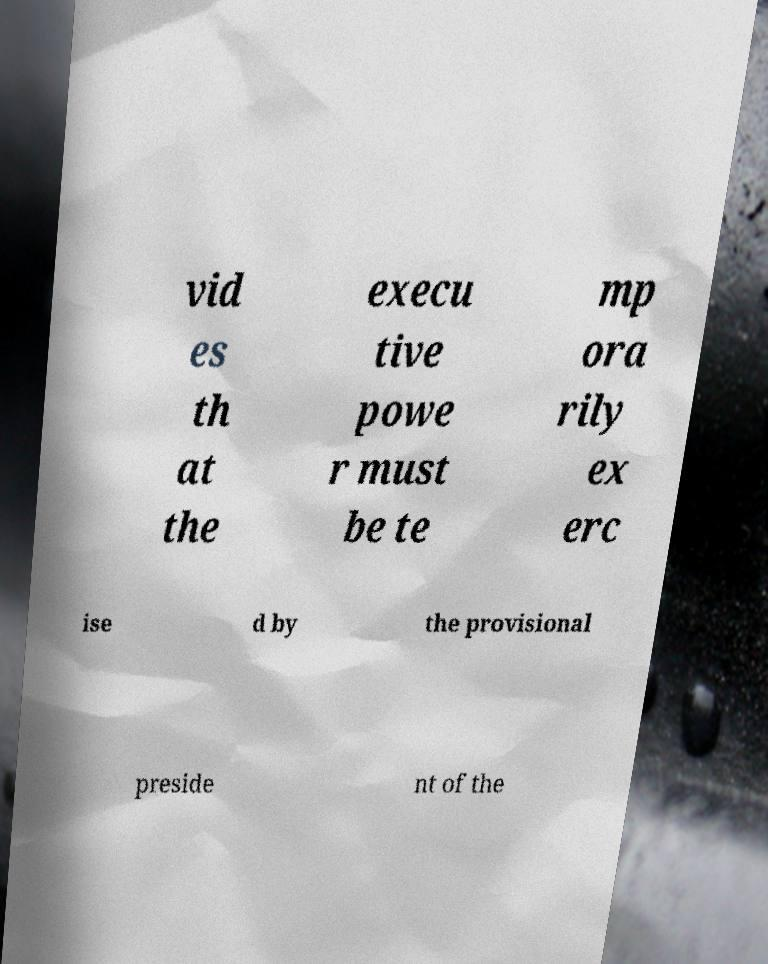Can you accurately transcribe the text from the provided image for me? vid es th at the execu tive powe r must be te mp ora rily ex erc ise d by the provisional preside nt of the 